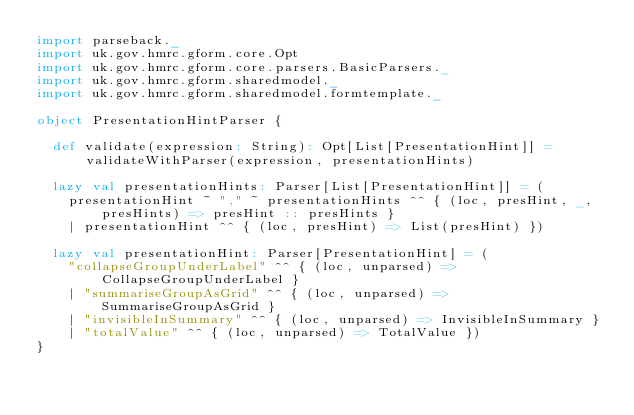<code> <loc_0><loc_0><loc_500><loc_500><_Scala_>import parseback._
import uk.gov.hmrc.gform.core.Opt
import uk.gov.hmrc.gform.core.parsers.BasicParsers._
import uk.gov.hmrc.gform.sharedmodel._
import uk.gov.hmrc.gform.sharedmodel.formtemplate._

object PresentationHintParser {

  def validate(expression: String): Opt[List[PresentationHint]] = validateWithParser(expression, presentationHints)

  lazy val presentationHints: Parser[List[PresentationHint]] = (
    presentationHint ~ "," ~ presentationHints ^^ { (loc, presHint, _, presHints) => presHint :: presHints }
    | presentationHint ^^ { (loc, presHint) => List(presHint) })

  lazy val presentationHint: Parser[PresentationHint] = (
    "collapseGroupUnderLabel" ^^ { (loc, unparsed) => CollapseGroupUnderLabel }
    | "summariseGroupAsGrid" ^^ { (loc, unparsed) => SummariseGroupAsGrid }
    | "invisibleInSummary" ^^ { (loc, unparsed) => InvisibleInSummary }
    | "totalValue" ^^ { (loc, unparsed) => TotalValue })
}
</code> 